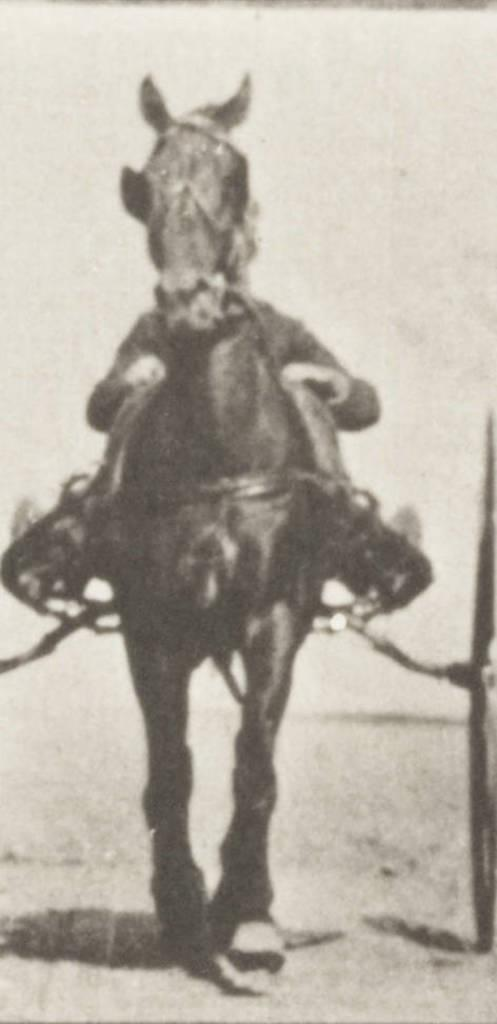What is the main subject of the image? There is a person in the image. What is the person doing in the image? The person is riding a horse cart. What type of skate is the person using to ride the horse cart? There is no skate present in the image; the person is riding a horse cart. What is the size of the pet accompanying the person in the image? There is no pet present in the image; the person is riding a horse cart. 